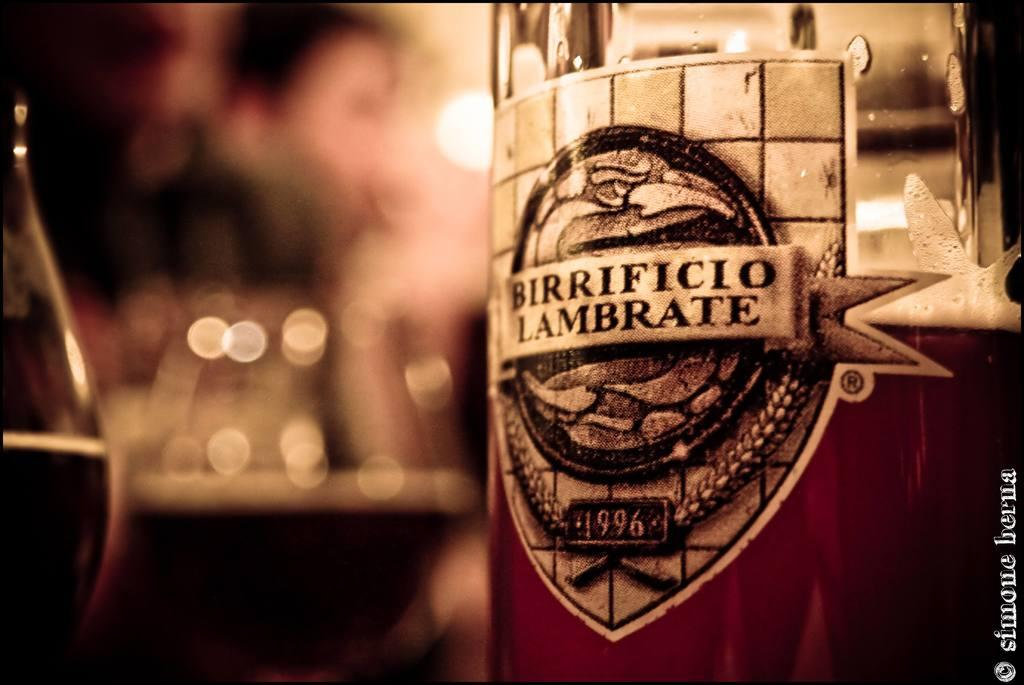<image>
Present a compact description of the photo's key features. Bottle of Birrificio Lambrate next to some half full glasses. 